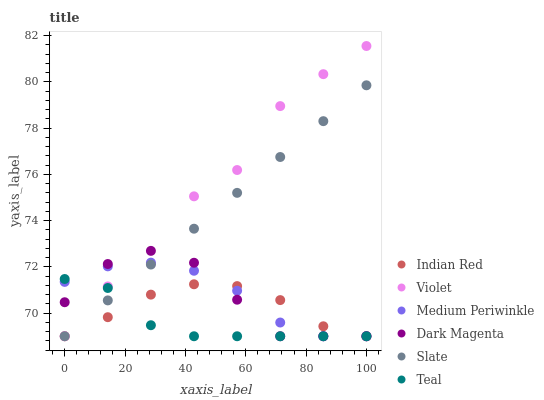Does Teal have the minimum area under the curve?
Answer yes or no. Yes. Does Violet have the maximum area under the curve?
Answer yes or no. Yes. Does Slate have the minimum area under the curve?
Answer yes or no. No. Does Slate have the maximum area under the curve?
Answer yes or no. No. Is Slate the smoothest?
Answer yes or no. Yes. Is Violet the roughest?
Answer yes or no. Yes. Is Medium Periwinkle the smoothest?
Answer yes or no. No. Is Medium Periwinkle the roughest?
Answer yes or no. No. Does Dark Magenta have the lowest value?
Answer yes or no. Yes. Does Violet have the highest value?
Answer yes or no. Yes. Does Slate have the highest value?
Answer yes or no. No. Does Medium Periwinkle intersect Teal?
Answer yes or no. Yes. Is Medium Periwinkle less than Teal?
Answer yes or no. No. Is Medium Periwinkle greater than Teal?
Answer yes or no. No. 